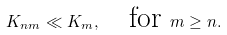<formula> <loc_0><loc_0><loc_500><loc_500>K _ { n m } \ll K _ { m } , \quad \text {for } m \geq n .</formula> 